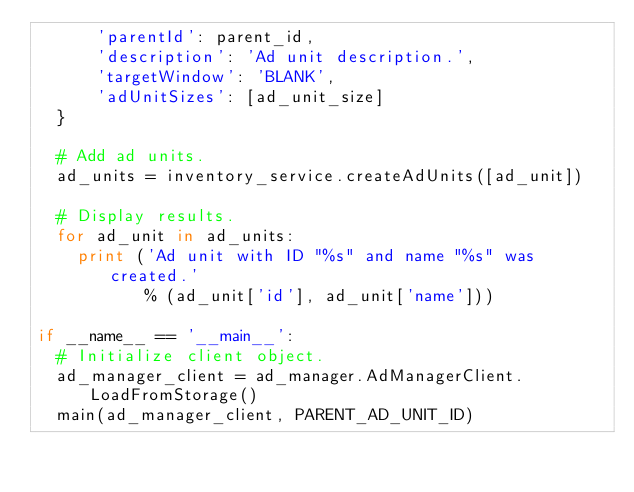Convert code to text. <code><loc_0><loc_0><loc_500><loc_500><_Python_>      'parentId': parent_id,
      'description': 'Ad unit description.',
      'targetWindow': 'BLANK',
      'adUnitSizes': [ad_unit_size]
  }

  # Add ad units.
  ad_units = inventory_service.createAdUnits([ad_unit])

  # Display results.
  for ad_unit in ad_units:
    print ('Ad unit with ID "%s" and name "%s" was created.'
           % (ad_unit['id'], ad_unit['name']))

if __name__ == '__main__':
  # Initialize client object.
  ad_manager_client = ad_manager.AdManagerClient.LoadFromStorage()
  main(ad_manager_client, PARENT_AD_UNIT_ID)
</code> 